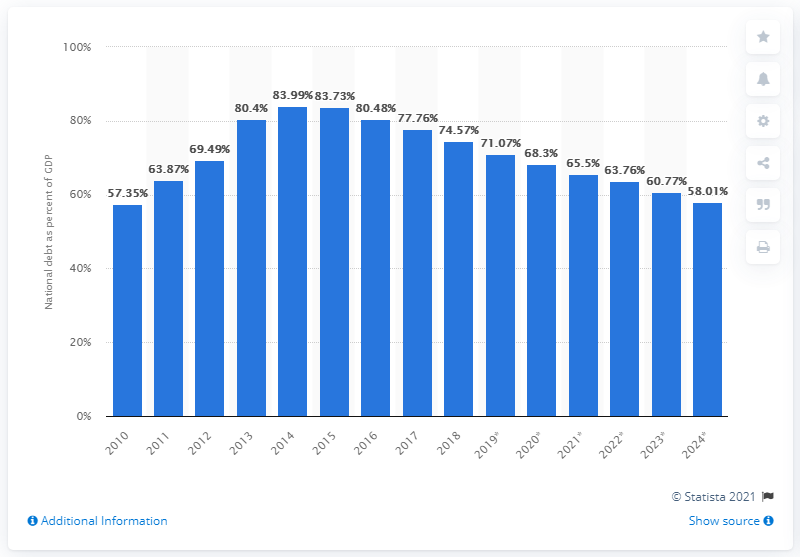Specify some key components in this picture. In 2018, the national debt of Croatia was 74.57. 